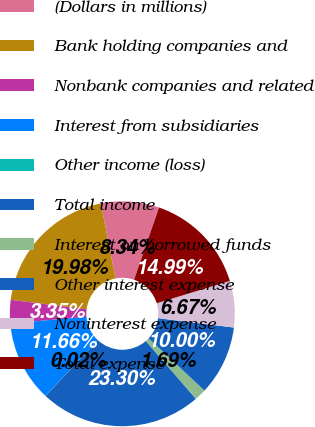<chart> <loc_0><loc_0><loc_500><loc_500><pie_chart><fcel>(Dollars in millions)<fcel>Bank holding companies and<fcel>Nonbank companies and related<fcel>Interest from subsidiaries<fcel>Other income (loss)<fcel>Total income<fcel>Interest on borrowed funds<fcel>Other interest expense<fcel>Noninterest expense<fcel>Total expense<nl><fcel>8.34%<fcel>19.98%<fcel>3.35%<fcel>11.66%<fcel>0.02%<fcel>23.3%<fcel>1.69%<fcel>10.0%<fcel>6.67%<fcel>14.99%<nl></chart> 